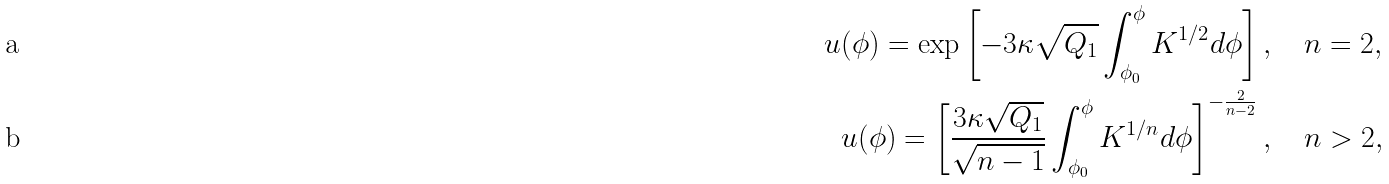Convert formula to latex. <formula><loc_0><loc_0><loc_500><loc_500>u ( \phi ) = \exp \left [ - 3 \kappa \sqrt { Q _ { 1 } } \int _ { \phi _ { 0 } } ^ { \phi } K ^ { 1 / 2 } d \phi \right ] , & \quad \, n = 2 , \\ u ( \phi ) = \left [ \frac { 3 \kappa \sqrt { Q _ { 1 } } } { \sqrt { n - 1 } } \int _ { \phi _ { 0 } } ^ { \phi } K ^ { 1 / n } d \phi \right ] ^ { - \frac { 2 } { n - 2 } } , & \quad \, n > 2 ,</formula> 